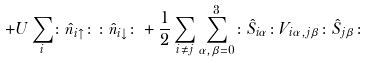<formula> <loc_0><loc_0><loc_500><loc_500>+ U \sum _ { i } \colon \hat { n } _ { i \uparrow } \colon \colon \hat { n } _ { i \downarrow } \colon + \frac { 1 } { 2 } \sum _ { i \neq j } \sum _ { \alpha , \beta = 0 } ^ { 3 } \colon \hat { S } _ { i \alpha } \colon V _ { i \alpha , j \beta } \colon \hat { S } _ { j \beta } \colon</formula> 